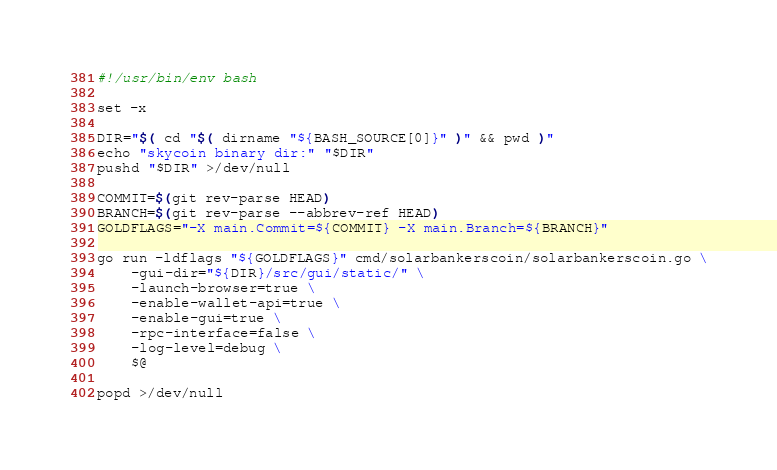<code> <loc_0><loc_0><loc_500><loc_500><_Bash_>#!/usr/bin/env bash

set -x

DIR="$( cd "$( dirname "${BASH_SOURCE[0]}" )" && pwd )"
echo "skycoin binary dir:" "$DIR"
pushd "$DIR" >/dev/null

COMMIT=$(git rev-parse HEAD)
BRANCH=$(git rev-parse --abbrev-ref HEAD)
GOLDFLAGS="-X main.Commit=${COMMIT} -X main.Branch=${BRANCH}"

go run -ldflags "${GOLDFLAGS}" cmd/solarbankerscoin/solarbankerscoin.go \
    -gui-dir="${DIR}/src/gui/static/" \
    -launch-browser=true \
    -enable-wallet-api=true \
    -enable-gui=true \
    -rpc-interface=false \
    -log-level=debug \
    $@

popd >/dev/null
</code> 